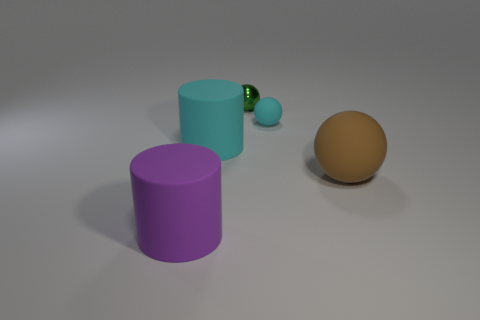Subtract all cyan spheres. Subtract all purple cubes. How many spheres are left? 2 Add 1 brown matte spheres. How many objects exist? 6 Subtract all cylinders. How many objects are left? 3 Add 2 cyan rubber objects. How many cyan rubber objects are left? 4 Add 4 yellow shiny things. How many yellow shiny things exist? 4 Subtract 0 yellow cylinders. How many objects are left? 5 Subtract all purple metal things. Subtract all purple matte cylinders. How many objects are left? 4 